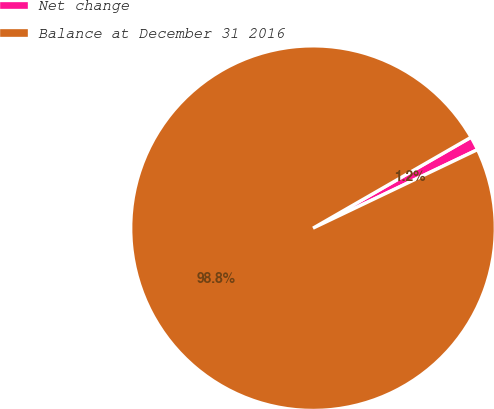Convert chart. <chart><loc_0><loc_0><loc_500><loc_500><pie_chart><fcel>Net change<fcel>Balance at December 31 2016<nl><fcel>1.22%<fcel>98.78%<nl></chart> 